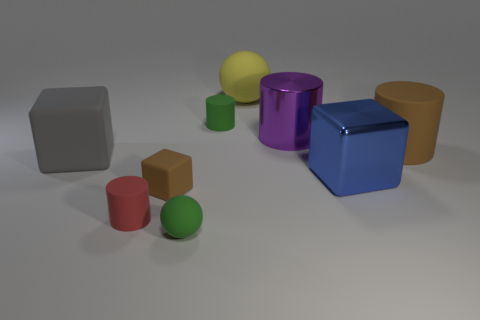What is the color of the other small matte thing that is the same shape as the blue object?
Your answer should be very brief. Brown. What is the shape of the purple thing that is behind the big brown matte thing?
Provide a succinct answer. Cylinder. Are there any tiny brown rubber cubes right of the shiny cylinder?
Offer a very short reply. No. Is there any other thing that is the same size as the red thing?
Your answer should be very brief. Yes. What is the color of the object that is made of the same material as the large blue block?
Your answer should be very brief. Purple. Does the cube that is left of the small brown block have the same color as the large metal object to the right of the metallic cylinder?
Ensure brevity in your answer.  No. How many cylinders are yellow objects or green rubber things?
Provide a succinct answer. 1. Are there the same number of yellow matte objects that are in front of the tiny green matte cylinder and matte objects?
Provide a short and direct response. No. There is a block that is right of the green sphere that is in front of the brown rubber object right of the green matte ball; what is it made of?
Offer a terse response. Metal. What is the material of the tiny block that is the same color as the large rubber cylinder?
Your response must be concise. Rubber. 